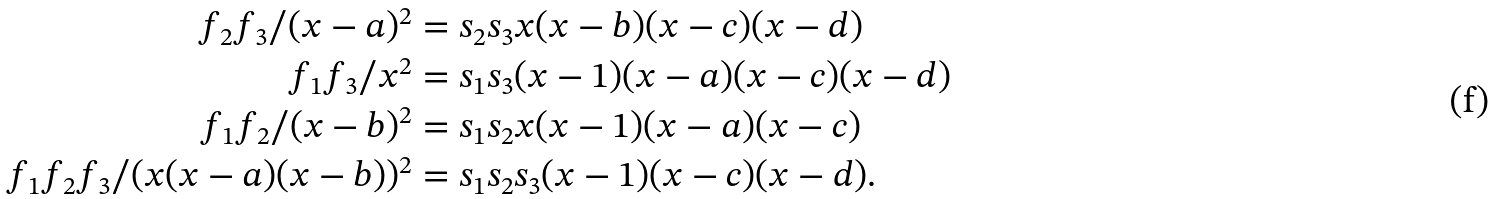<formula> <loc_0><loc_0><loc_500><loc_500>f _ { 2 } f _ { 3 } / ( x - a ) ^ { 2 } & = s _ { 2 } s _ { 3 } x ( x - b ) ( x - c ) ( x - d ) \\ f _ { 1 } f _ { 3 } / x ^ { 2 } & = s _ { 1 } s _ { 3 } ( x - 1 ) ( x - a ) ( x - c ) ( x - d ) \\ f _ { 1 } f _ { 2 } / ( x - b ) ^ { 2 } & = s _ { 1 } s _ { 2 } x ( x - 1 ) ( x - a ) ( x - c ) \\ f _ { 1 } f _ { 2 } f _ { 3 } / ( x ( x - a ) ( x - b ) ) ^ { 2 } & = s _ { 1 } s _ { 2 } s _ { 3 } ( x - 1 ) ( x - c ) ( x - d ) .</formula> 